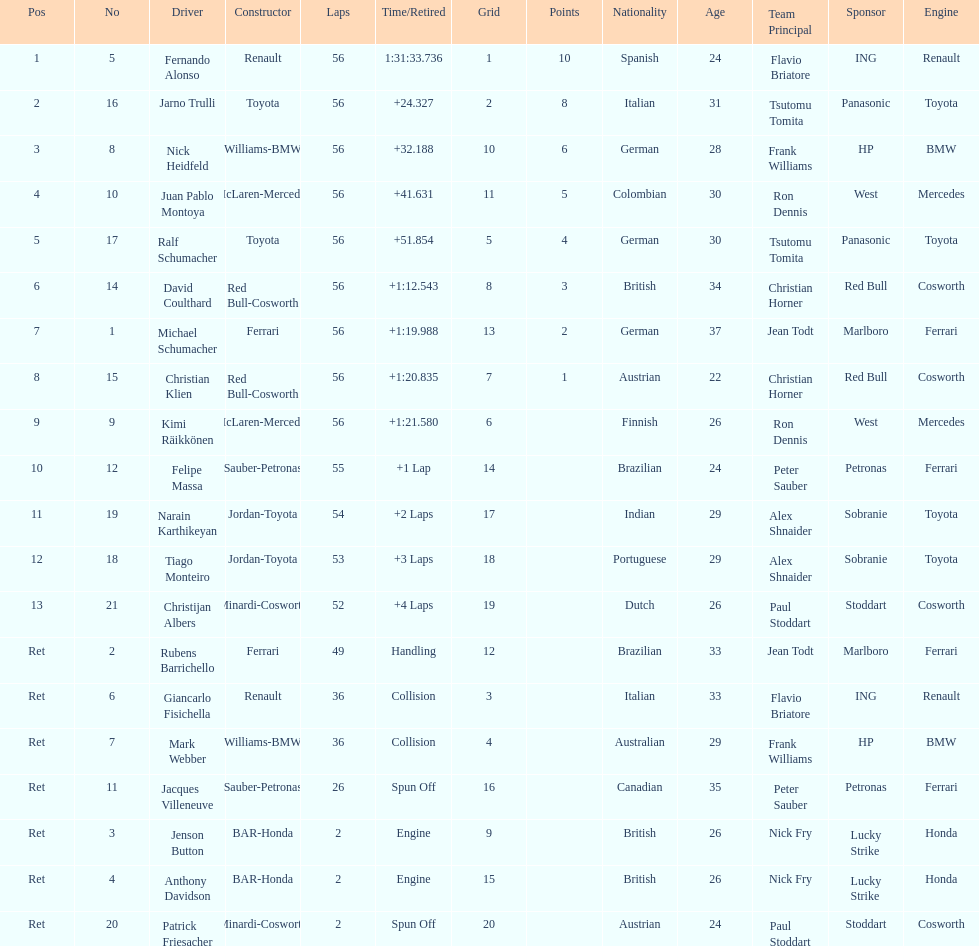What were the total number of laps completed by the 1st position winner? 56. 